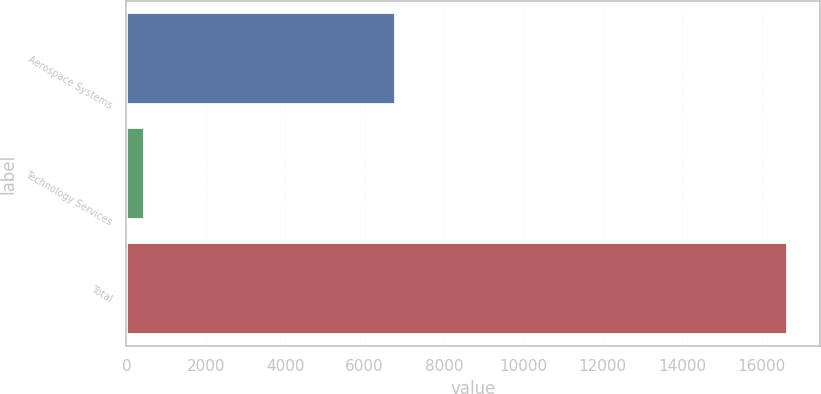<chart> <loc_0><loc_0><loc_500><loc_500><bar_chart><fcel>Aerospace Systems<fcel>Technology Services<fcel>Total<nl><fcel>6775<fcel>434<fcel>16649<nl></chart> 